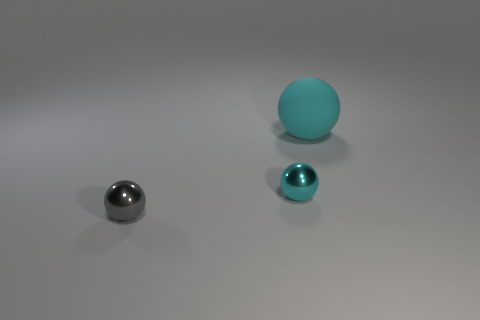Subtract all blue cylinders. How many cyan balls are left? 2 Add 1 tiny gray objects. How many objects exist? 4 Subtract all large brown rubber cubes. Subtract all cyan rubber spheres. How many objects are left? 2 Add 3 large cyan things. How many large cyan things are left? 4 Add 1 cyan shiny balls. How many cyan shiny balls exist? 2 Subtract 0 brown balls. How many objects are left? 3 